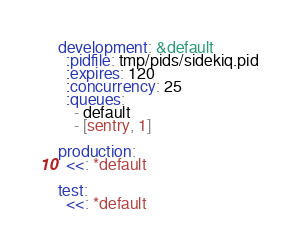Convert code to text. <code><loc_0><loc_0><loc_500><loc_500><_YAML_>development: &default
  :pidfile: tmp/pids/sidekiq.pid
  :expires: 120
  :concurrency: 25
  :queues:
    - default
    - [sentry, 1]

production:
  <<: *default

test:
  <<: *default
</code> 